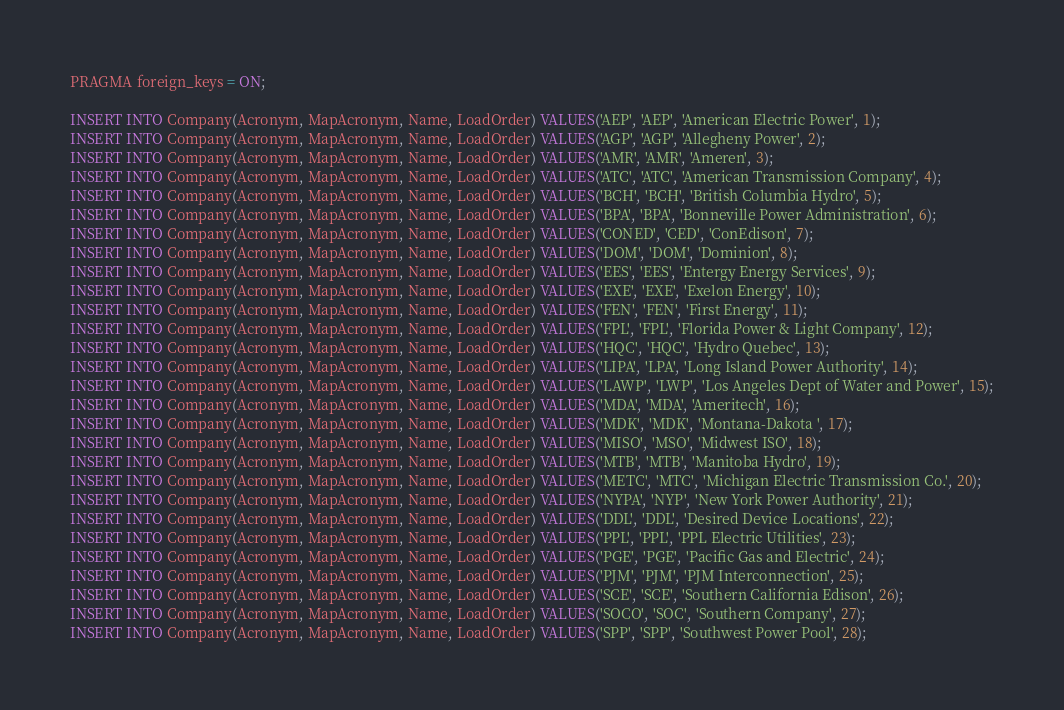Convert code to text. <code><loc_0><loc_0><loc_500><loc_500><_SQL_>PRAGMA foreign_keys = ON;

INSERT INTO Company(Acronym, MapAcronym, Name, LoadOrder) VALUES('AEP', 'AEP', 'American Electric Power', 1);
INSERT INTO Company(Acronym, MapAcronym, Name, LoadOrder) VALUES('AGP', 'AGP', 'Allegheny Power', 2);
INSERT INTO Company(Acronym, MapAcronym, Name, LoadOrder) VALUES('AMR', 'AMR', 'Ameren', 3);
INSERT INTO Company(Acronym, MapAcronym, Name, LoadOrder) VALUES('ATC', 'ATC', 'American Transmission Company', 4);
INSERT INTO Company(Acronym, MapAcronym, Name, LoadOrder) VALUES('BCH', 'BCH', 'British Columbia Hydro', 5);
INSERT INTO Company(Acronym, MapAcronym, Name, LoadOrder) VALUES('BPA', 'BPA', 'Bonneville Power Administration', 6);
INSERT INTO Company(Acronym, MapAcronym, Name, LoadOrder) VALUES('CONED', 'CED', 'ConEdison', 7);
INSERT INTO Company(Acronym, MapAcronym, Name, LoadOrder) VALUES('DOM', 'DOM', 'Dominion', 8);
INSERT INTO Company(Acronym, MapAcronym, Name, LoadOrder) VALUES('EES', 'EES', 'Entergy Energy Services', 9);
INSERT INTO Company(Acronym, MapAcronym, Name, LoadOrder) VALUES('EXE', 'EXE', 'Exelon Energy', 10);
INSERT INTO Company(Acronym, MapAcronym, Name, LoadOrder) VALUES('FEN', 'FEN', 'First Energy', 11);
INSERT INTO Company(Acronym, MapAcronym, Name, LoadOrder) VALUES('FPL', 'FPL', 'Florida Power & Light Company', 12);
INSERT INTO Company(Acronym, MapAcronym, Name, LoadOrder) VALUES('HQC', 'HQC', 'Hydro Quebec', 13);
INSERT INTO Company(Acronym, MapAcronym, Name, LoadOrder) VALUES('LIPA', 'LPA', 'Long Island Power Authority', 14);
INSERT INTO Company(Acronym, MapAcronym, Name, LoadOrder) VALUES('LAWP', 'LWP', 'Los Angeles Dept of Water and Power', 15);
INSERT INTO Company(Acronym, MapAcronym, Name, LoadOrder) VALUES('MDA', 'MDA', 'Ameritech', 16);
INSERT INTO Company(Acronym, MapAcronym, Name, LoadOrder) VALUES('MDK', 'MDK', 'Montana-Dakota ', 17);
INSERT INTO Company(Acronym, MapAcronym, Name, LoadOrder) VALUES('MISO', 'MSO', 'Midwest ISO', 18);
INSERT INTO Company(Acronym, MapAcronym, Name, LoadOrder) VALUES('MTB', 'MTB', 'Manitoba Hydro', 19);
INSERT INTO Company(Acronym, MapAcronym, Name, LoadOrder) VALUES('METC', 'MTC', 'Michigan Electric Transmission Co.', 20);
INSERT INTO Company(Acronym, MapAcronym, Name, LoadOrder) VALUES('NYPA', 'NYP', 'New York Power Authority', 21);
INSERT INTO Company(Acronym, MapAcronym, Name, LoadOrder) VALUES('DDL', 'DDL', 'Desired Device Locations', 22);
INSERT INTO Company(Acronym, MapAcronym, Name, LoadOrder) VALUES('PPL', 'PPL', 'PPL Electric Utilities', 23);
INSERT INTO Company(Acronym, MapAcronym, Name, LoadOrder) VALUES('PGE', 'PGE', 'Pacific Gas and Electric', 24);
INSERT INTO Company(Acronym, MapAcronym, Name, LoadOrder) VALUES('PJM', 'PJM', 'PJM Interconnection', 25);
INSERT INTO Company(Acronym, MapAcronym, Name, LoadOrder) VALUES('SCE', 'SCE', 'Southern California Edison', 26);
INSERT INTO Company(Acronym, MapAcronym, Name, LoadOrder) VALUES('SOCO', 'SOC', 'Southern Company', 27);
INSERT INTO Company(Acronym, MapAcronym, Name, LoadOrder) VALUES('SPP', 'SPP', 'Southwest Power Pool', 28);</code> 